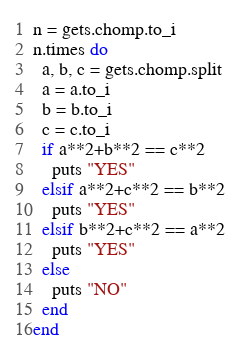<code> <loc_0><loc_0><loc_500><loc_500><_Ruby_>n = gets.chomp.to_i
n.times do
  a, b, c = gets.chomp.split
  a = a.to_i
  b = b.to_i
  c = c.to_i
  if a**2+b**2 == c**2
    puts "YES"
  elsif a**2+c**2 == b**2
    puts "YES"
  elsif b**2+c**2 == a**2
    puts "YES"
  else
    puts "NO"
  end
end


</code> 